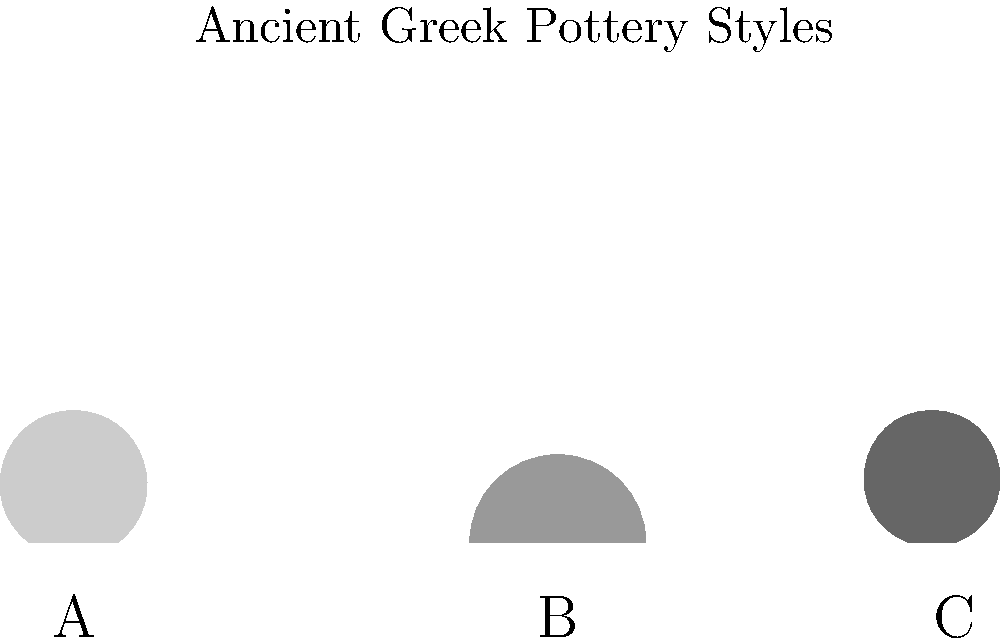As an English teacher with a passion for Greek mythology, you're creating a lesson on ancient Greek pottery. Identify the pottery style represented by shape B in the image, which was commonly used for mixing wine and water during symposia. To answer this question, let's analyze the shapes presented in the image and their characteristics:

1. Shape A: This is a tall, slender vessel with a narrow neck and two handles. It represents an amphora, typically used for storing and transporting liquids like wine or olive oil.

2. Shape B: This vessel has a wide, open mouth and a broad body that narrows towards the base. It's larger and more bowl-like than the other shapes. This shape is characteristic of a krater, which was indeed used for mixing wine and water during symposia (drinking parties) in ancient Greece.

3. Shape C: This is a tall, slim vessel with a single handle and a narrow neck. It represents a lekythos, often used for storing oils or perfumes, and commonly found in funerary contexts.

Given the question's context about mixing wine and water during symposia, and the distinctive wide, open shape of vessel B, we can confidently identify it as a krater.

Kraters were essential in Greek symposia because the ancient Greeks didn't drink their wine neat. They would mix wine with water in these large vessels before serving, making the krater a central piece in their social gatherings.
Answer: Krater 